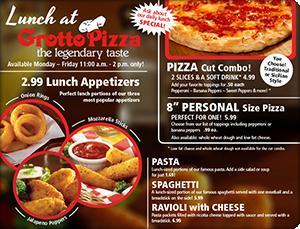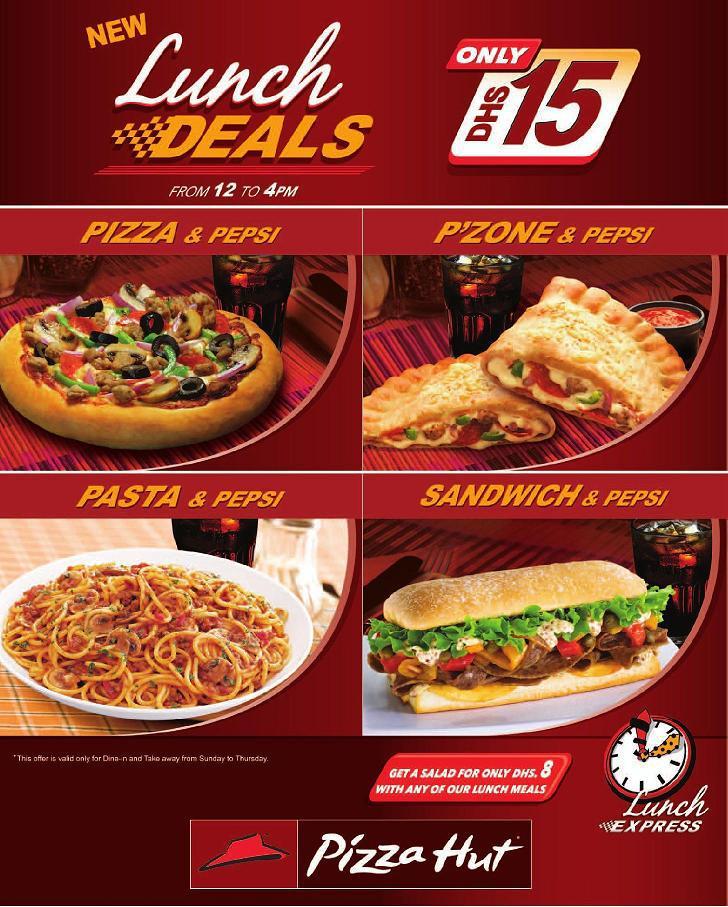The first image is the image on the left, the second image is the image on the right. Assess this claim about the two images: "The right image includes a cartoon clock and contains the same number of food items as the left image.". Correct or not? Answer yes or no. Yes. 